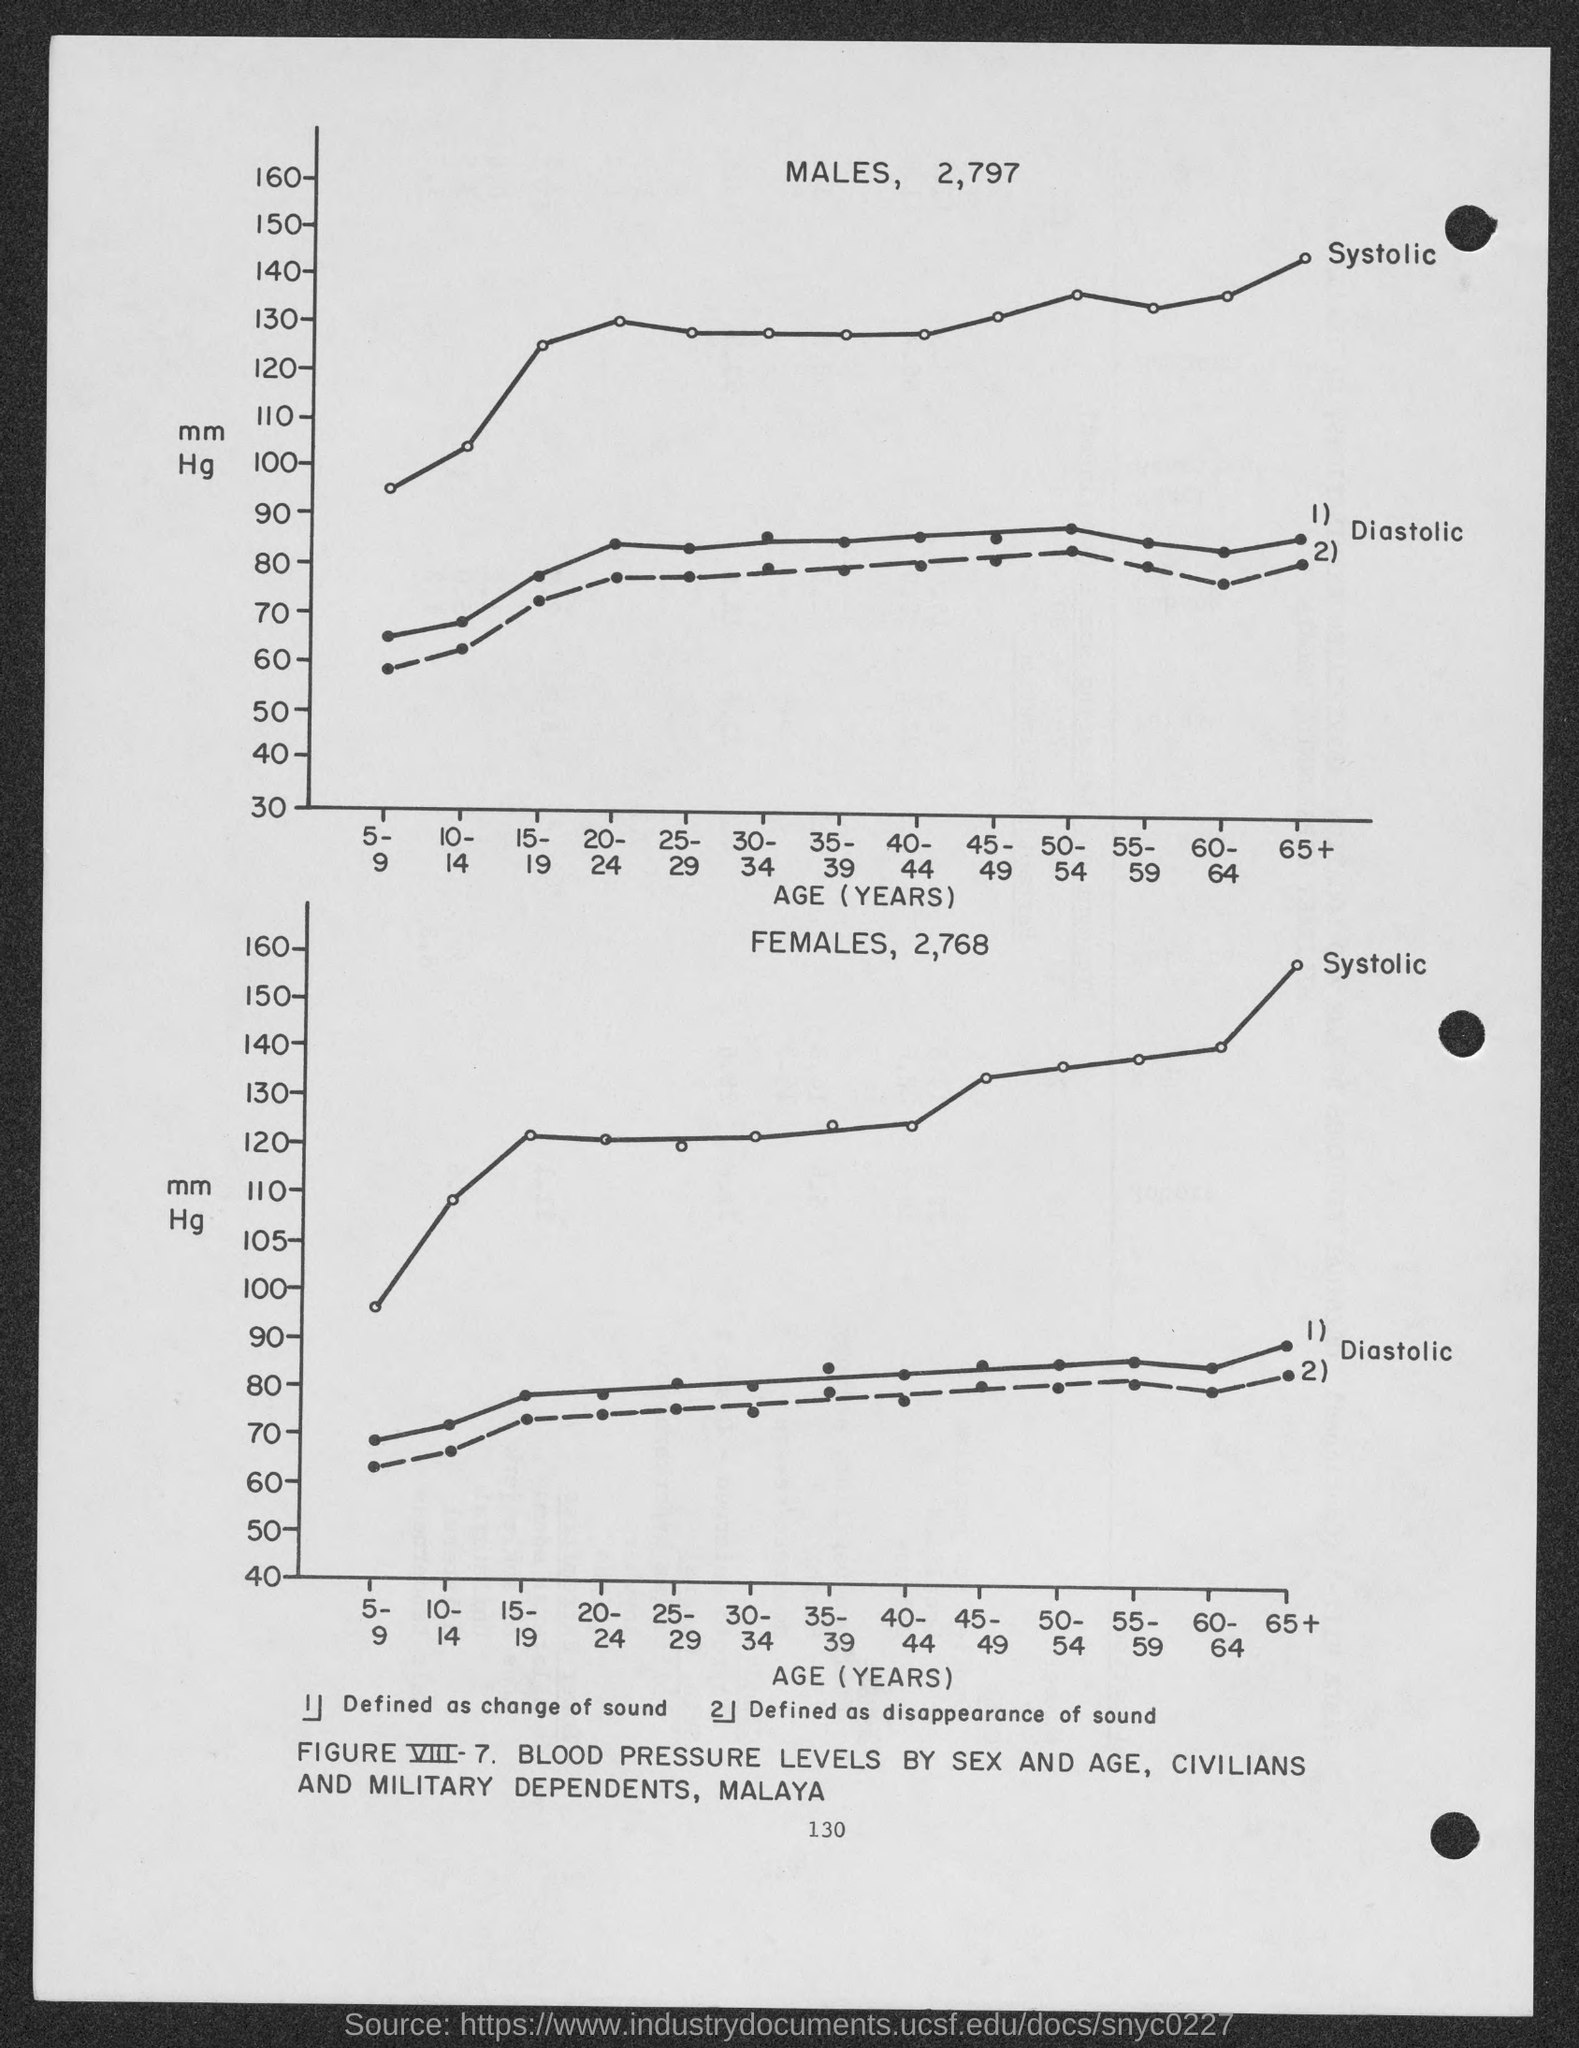Highlight a few significant elements in this photo. The number at the bottom of the page is 130. 